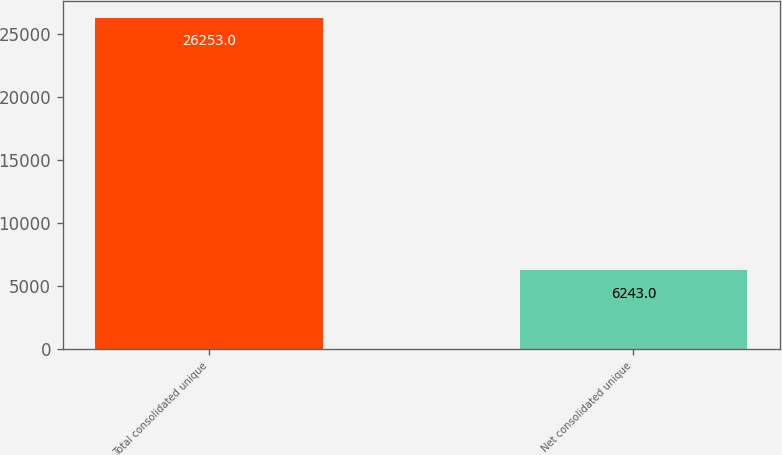Convert chart. <chart><loc_0><loc_0><loc_500><loc_500><bar_chart><fcel>Total consolidated unique<fcel>Net consolidated unique<nl><fcel>26253<fcel>6243<nl></chart> 